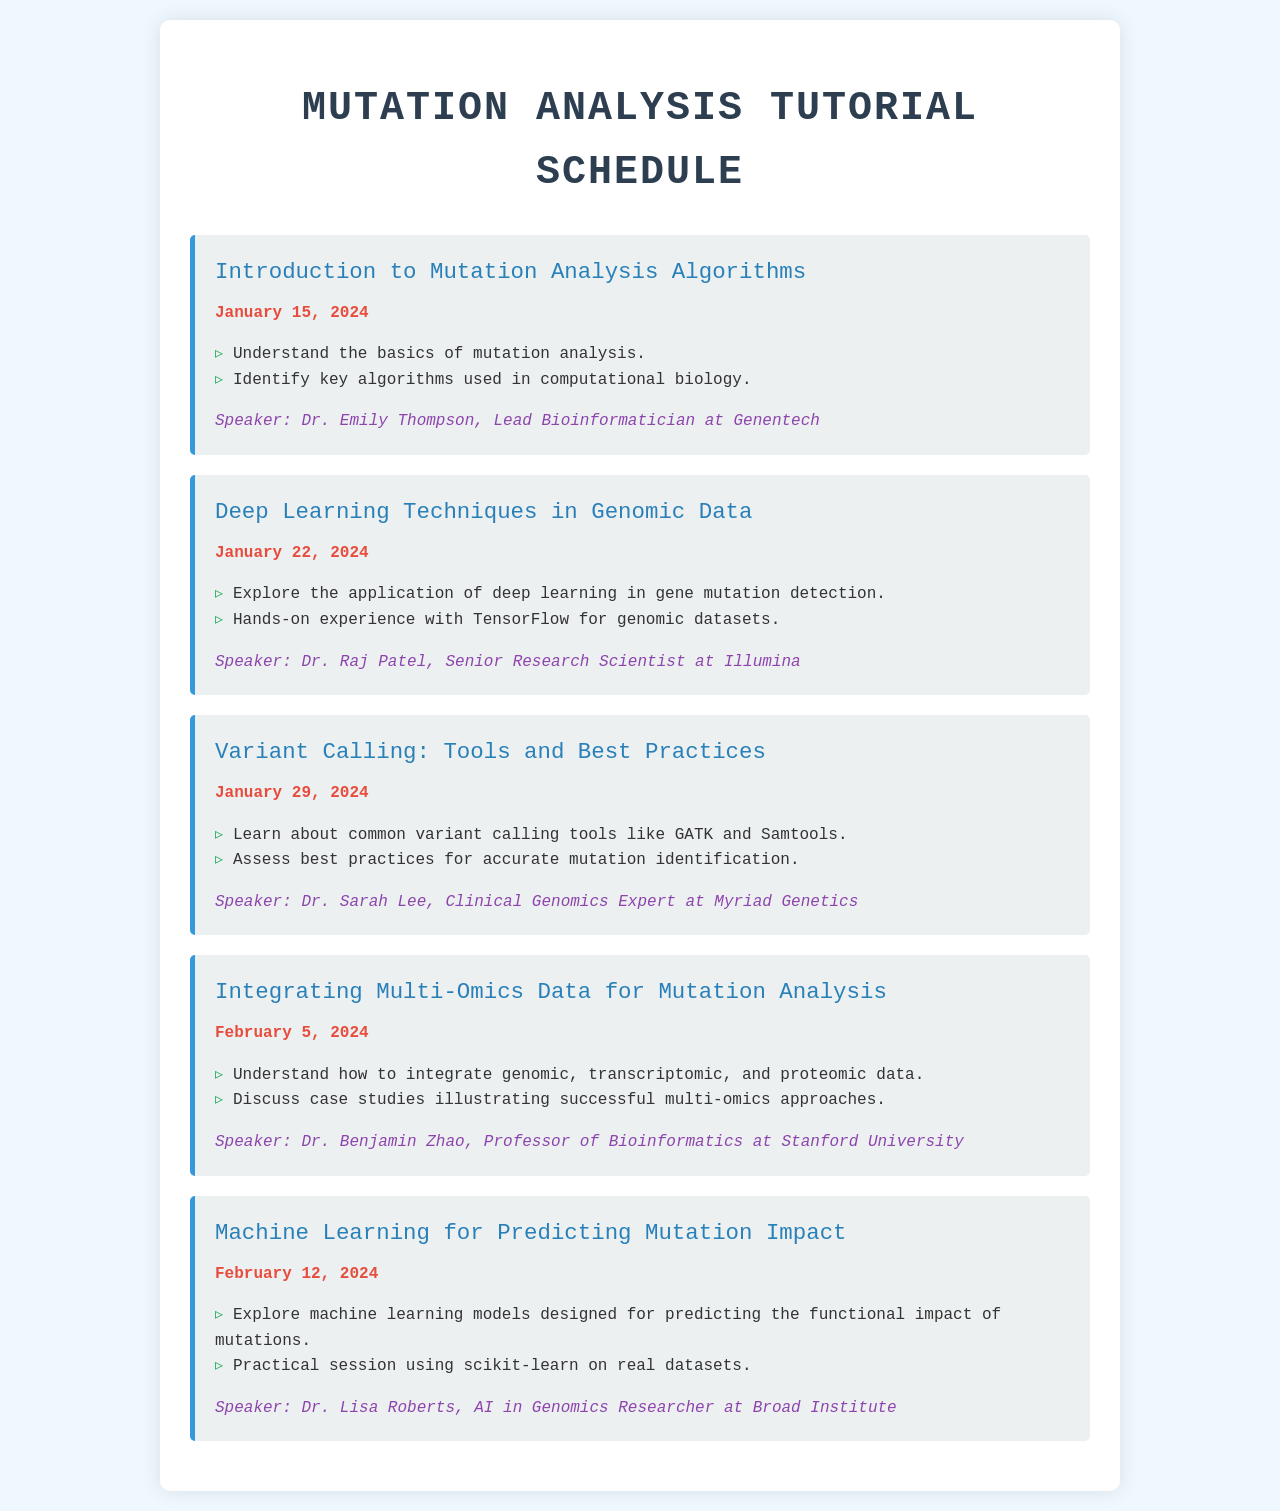What is the title of the first session? The title of the first session is specified in the document as "Introduction to Mutation Analysis Algorithms."
Answer: Introduction to Mutation Analysis Algorithms Who is the speaker for the session on Deep Learning Techniques? The speaker's name is listed with their professional affiliation in the document. For the second session, it's Dr. Raj Patel.
Answer: Dr. Raj Patel What date is the Variant Calling session scheduled? The document specifies the scheduled date for the Variant Calling session as January 29, 2024.
Answer: January 29, 2024 How many sessions are there in total? The total number of sessions is counted based on the entries in the document, totaling five sessions.
Answer: Five What is one objective of the session on Integrating Multi-Omics Data? The specific objective is detailed in the session's list of objectives in the document. One of them is about data integration.
Answer: Understand how to integrate genomic, transcriptomic, and proteomic data Which session focuses on machine learning models? The session's focus on machine learning is indicated by its title in the document, which mentions predicting mutation impact.
Answer: Machine Learning for Predicting Mutation Impact Who is the invited speaker for the final session? The document lists the speaker's name for the last session, which is Dr. Lisa Roberts.
Answer: Dr. Lisa Roberts 